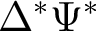Convert formula to latex. <formula><loc_0><loc_0><loc_500><loc_500>\Delta ^ { * } \Psi ^ { * }</formula> 